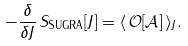<formula> <loc_0><loc_0><loc_500><loc_500>- \frac { \delta } { \delta J } \, S _ { \text {SUGRA} } [ J ] = \langle \, \mathcal { O [ A ] } \, \rangle _ { J } .</formula> 